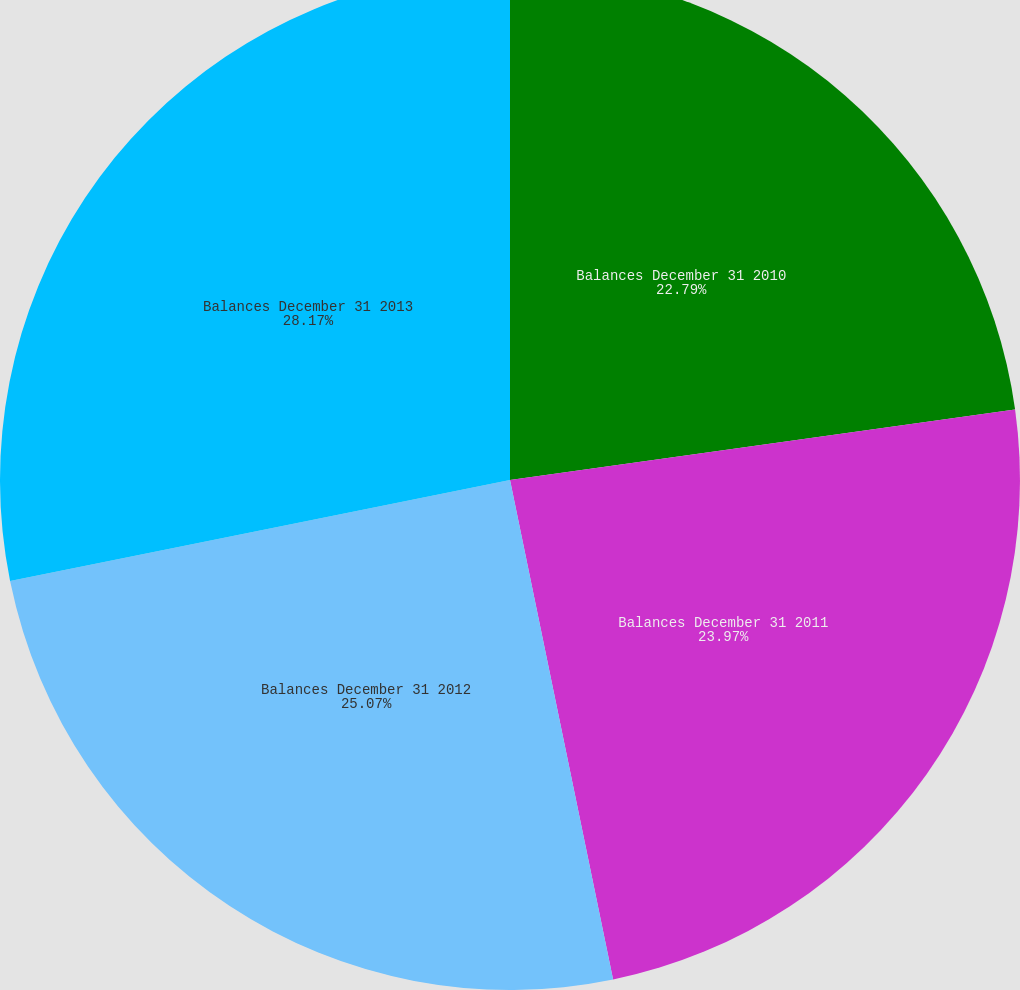<chart> <loc_0><loc_0><loc_500><loc_500><pie_chart><fcel>Balances December 31 2010<fcel>Balances December 31 2011<fcel>Balances December 31 2012<fcel>Balances December 31 2013<nl><fcel>22.79%<fcel>23.97%<fcel>25.07%<fcel>28.17%<nl></chart> 